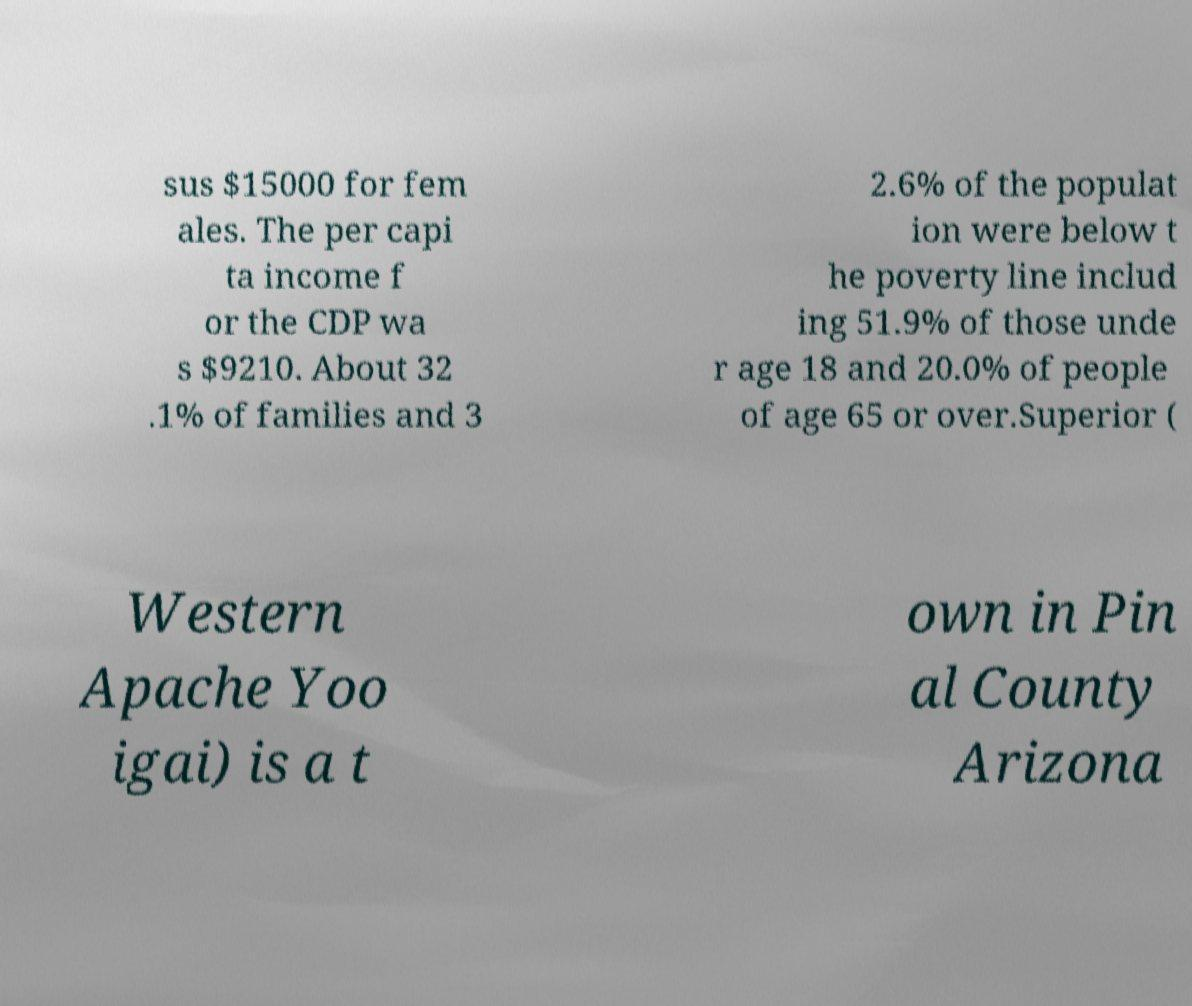Please read and relay the text visible in this image. What does it say? sus $15000 for fem ales. The per capi ta income f or the CDP wa s $9210. About 32 .1% of families and 3 2.6% of the populat ion were below t he poverty line includ ing 51.9% of those unde r age 18 and 20.0% of people of age 65 or over.Superior ( Western Apache Yoo igai) is a t own in Pin al County Arizona 